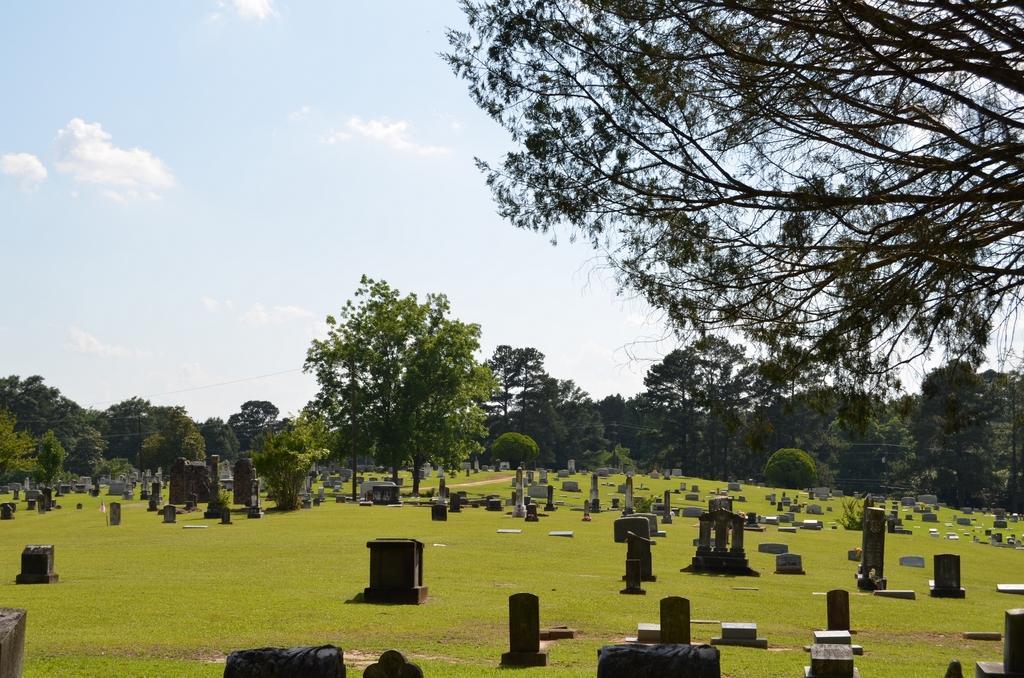Could you give a brief overview of what you see in this image? This picture is clicked outside. In the foreground we can see the graves of the persons and we can see there are some objects placed on the ground, the ground is covered with the green grass and we can see the plants and trees. In the background we can see the sky. 